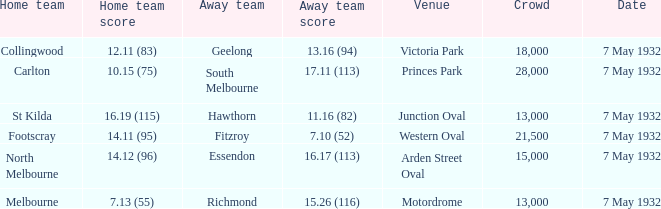What is the largest crowd with Away team score of 13.16 (94)? 18000.0. 